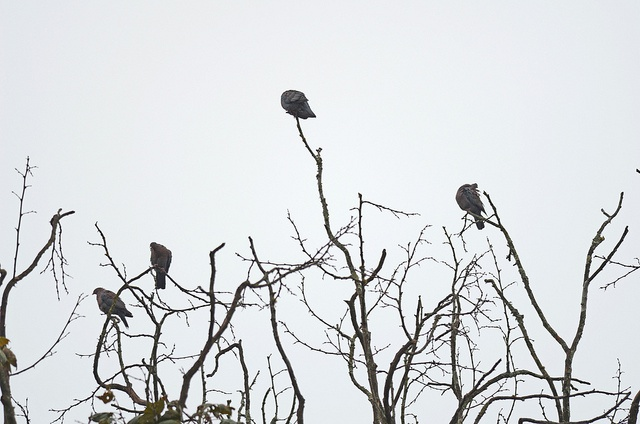Describe the objects in this image and their specific colors. I can see bird in lightgray, gray, white, black, and darkgray tones, bird in lightgray, black, and gray tones, bird in lightgray, gray, black, and darkgray tones, bird in lightgray, gray, black, and white tones, and bird in lightgray, olive, gray, and black tones in this image. 